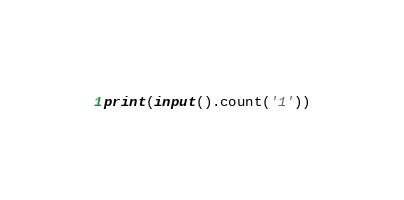<code> <loc_0><loc_0><loc_500><loc_500><_Python_>print(input().count('1'))</code> 